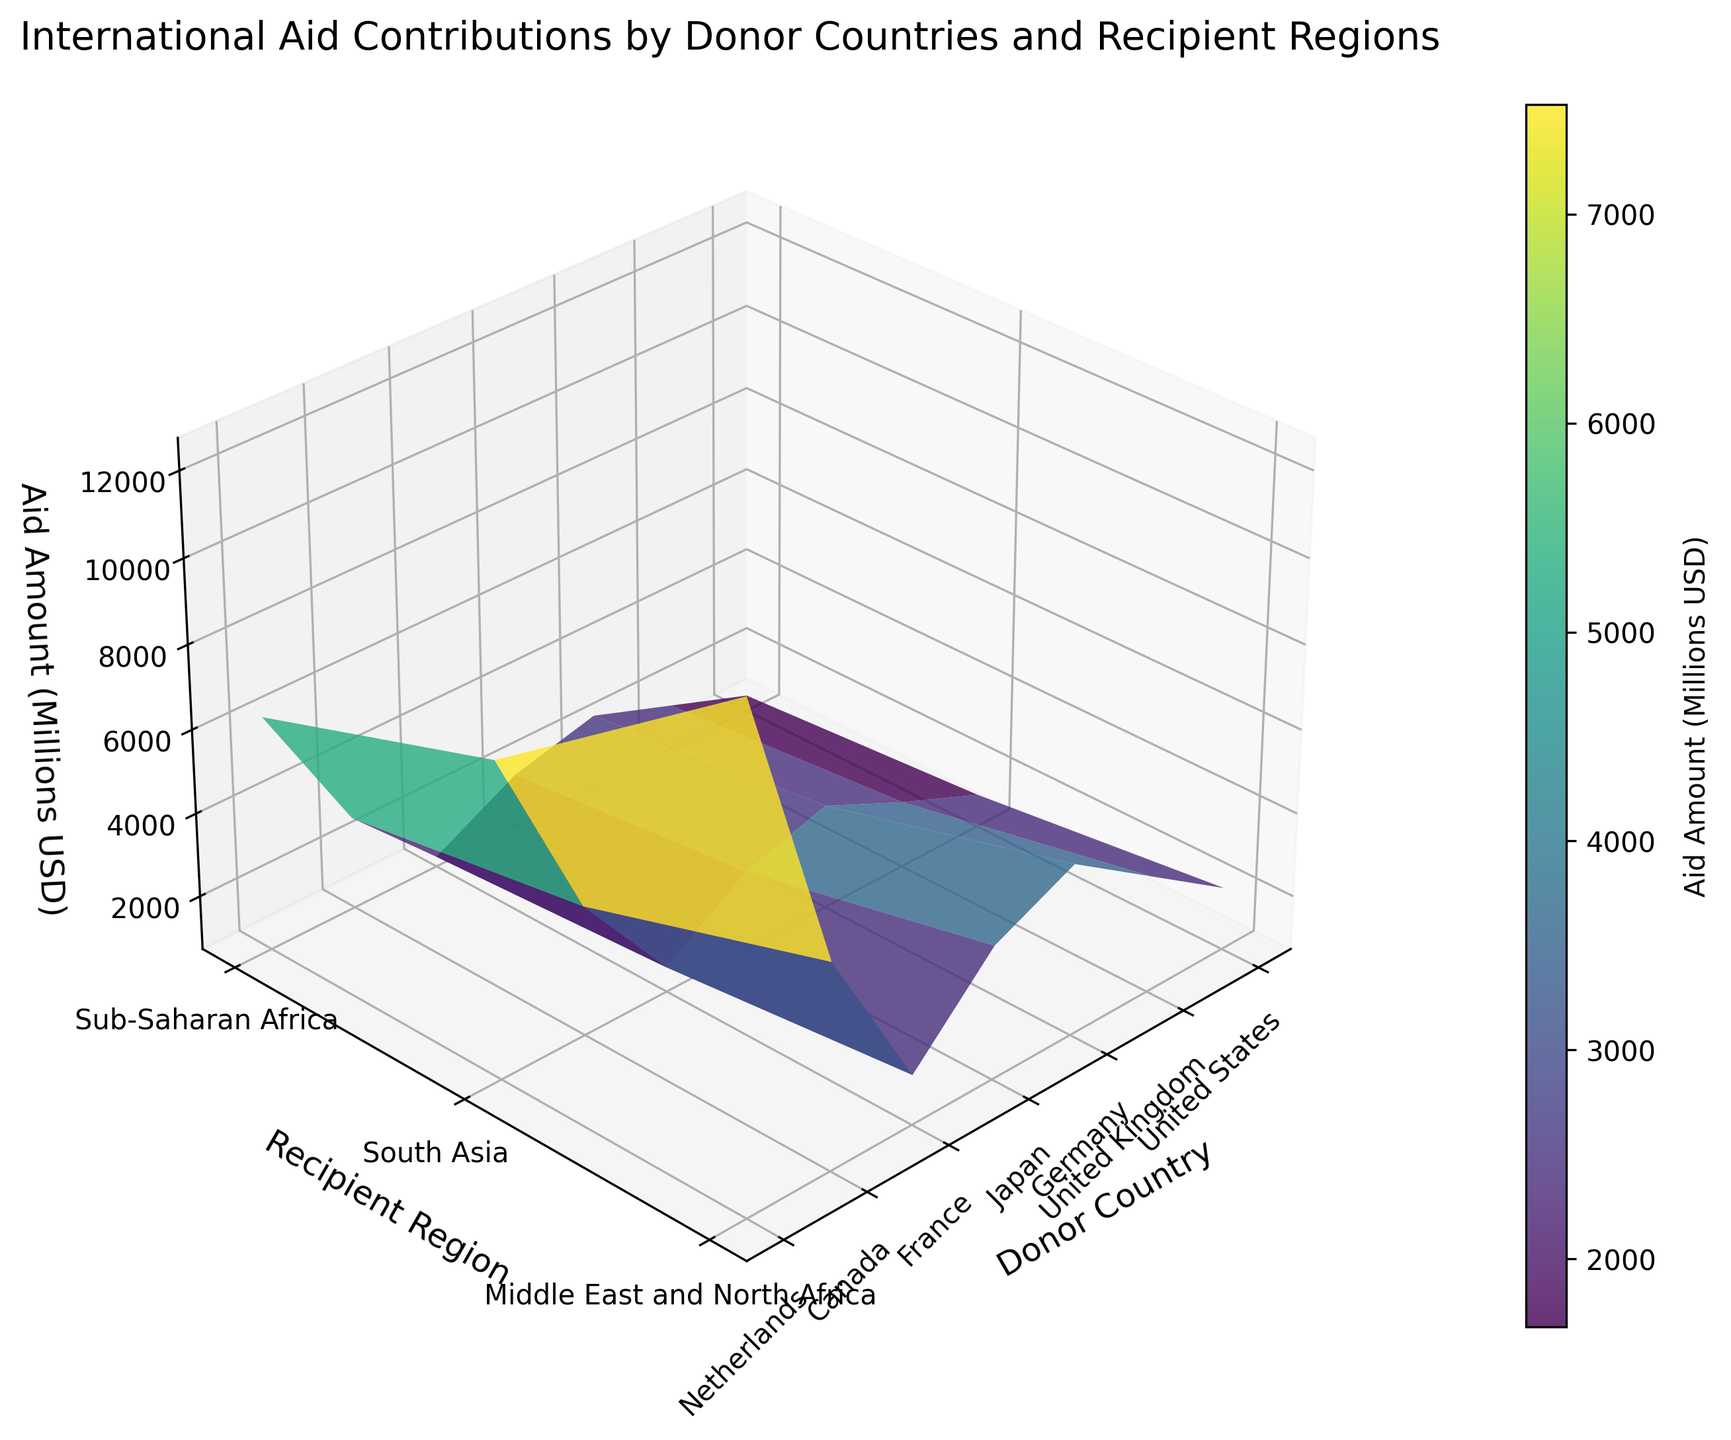What's the title of the figure? The title is typically located at the top or in a prominent position of the plot. In this figure, it's placed at the top with a larger and bolder font to make it easily noticeable.
Answer: International Aid Contributions by Donor Countries and Recipient Regions What are the axis labels? The labels for each axis help identify what each dimension of the plot represents. In this case, the x-axis represents "Donor Country," the y-axis represents "Recipient Region," and the z-axis represents "Aid Amount (Millions USD)."
Answer: Donor Country, Recipient Region, Aid Amount (Millions USD) Which donor country contributed the most aid to Sub-Saharan Africa? Locate Sub-Saharan Africa on the y-axis, then identify the highest point along the z-axis within the corresponding column for each donor country on the x-axis.
Answer: United States What is the total aid amount given to South Asia by the United States and the United Kingdom? Look at the z-axis values for both the United States and the United Kingdom directed towards South Asia. Sum these values: 8200 (US) + 3800 (UK).
Answer: 12000 Which region received the least aid from France? Locate France on the x-axis, then compare the heights of the plotted values for each corresponding region on the y-axis. The shortest height indicates the lowest aid amount.
Answer: Middle East and North Africa Among the listed donor countries, which one shows the least variability in aid contributions across regions? By observing the z-values (heights) for each donor country, determine which one has the most evenly distributed heights across all regions. Less variability indicates the aid amounts are more similar across different regions.
Answer: Canada Which donor country has a significant difference in aid contributions between Sub-Saharan Africa and the Middle East and North Africa? Compare the vertical differences in heights for each donor country between the two specified regions. Determine which country has the most noticeable height difference.
Answer: United States What is the average aid amount given by Germany across all regions? Extract the aid amounts given by Germany: 4800 (Sub-Saharan Africa), 3200 (South Asia), and 2500 (Middle East and North Africa). Then calculate their average: (4800 + 3200 + 2500) / 3.
Answer: 3500 Which donor country provides more aid to South Asia compared to the Middle East and North Africa? Compare the z-axis heights for aid amounts directed to South Asia and the Middle East and North Africa for each donor country. Identify which country has a higher aid amount for South Asia.
Answer: Germany 